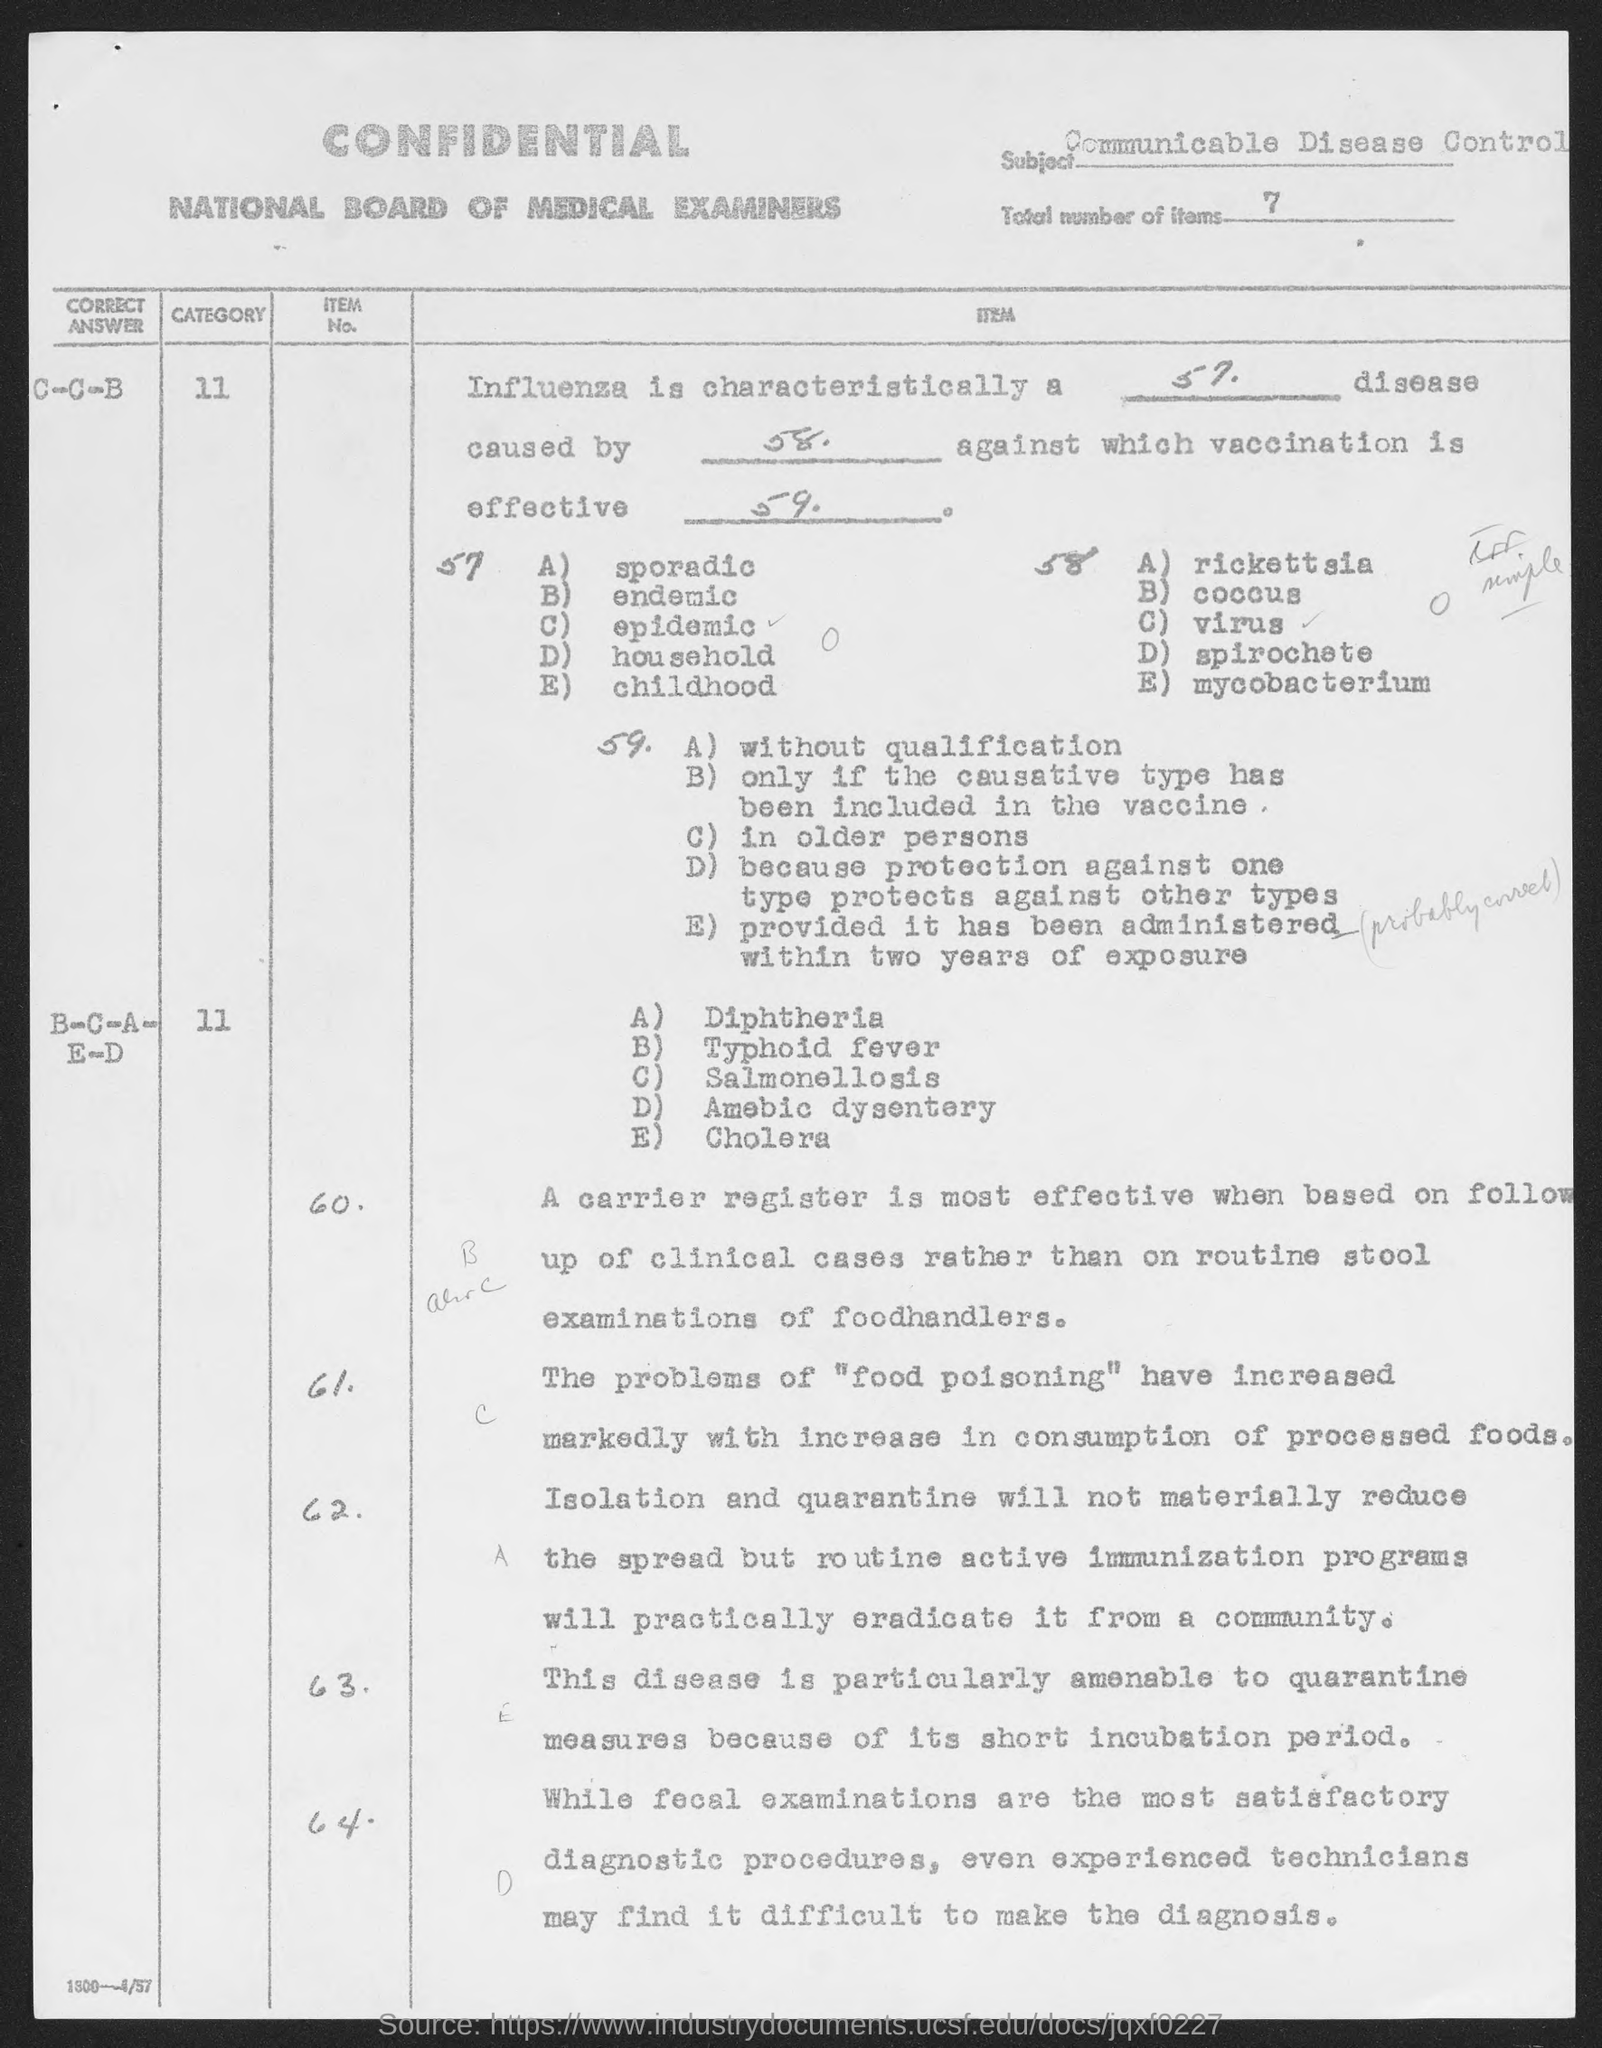Give some essential details in this illustration. The subject is "Communicable Disease Control. The total number of items is 7. 